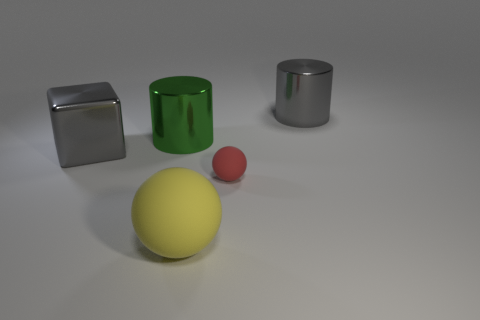Does the shiny cylinder in front of the gray cylinder have the same color as the big thing that is to the right of the large yellow thing?
Keep it short and to the point. No. There is a gray metallic cylinder that is on the right side of the cylinder to the left of the gray cylinder; how many shiny objects are right of it?
Provide a succinct answer. 0. What number of large cylinders are on the right side of the yellow object and to the left of the big gray cylinder?
Make the answer very short. 0. Is the number of big yellow spheres to the left of the gray cube greater than the number of green objects?
Make the answer very short. No. How many metallic cylinders are the same size as the yellow matte sphere?
Provide a short and direct response. 2. There is a metal cylinder that is the same color as the shiny cube; what is its size?
Provide a succinct answer. Large. What number of tiny objects are blue rubber spheres or gray metallic cubes?
Offer a terse response. 0. How many yellow matte objects are there?
Your answer should be very brief. 1. Are there the same number of green shiny objects in front of the tiny red rubber object and objects to the right of the yellow ball?
Make the answer very short. No. There is a large yellow rubber ball; are there any red matte objects in front of it?
Provide a short and direct response. No. 